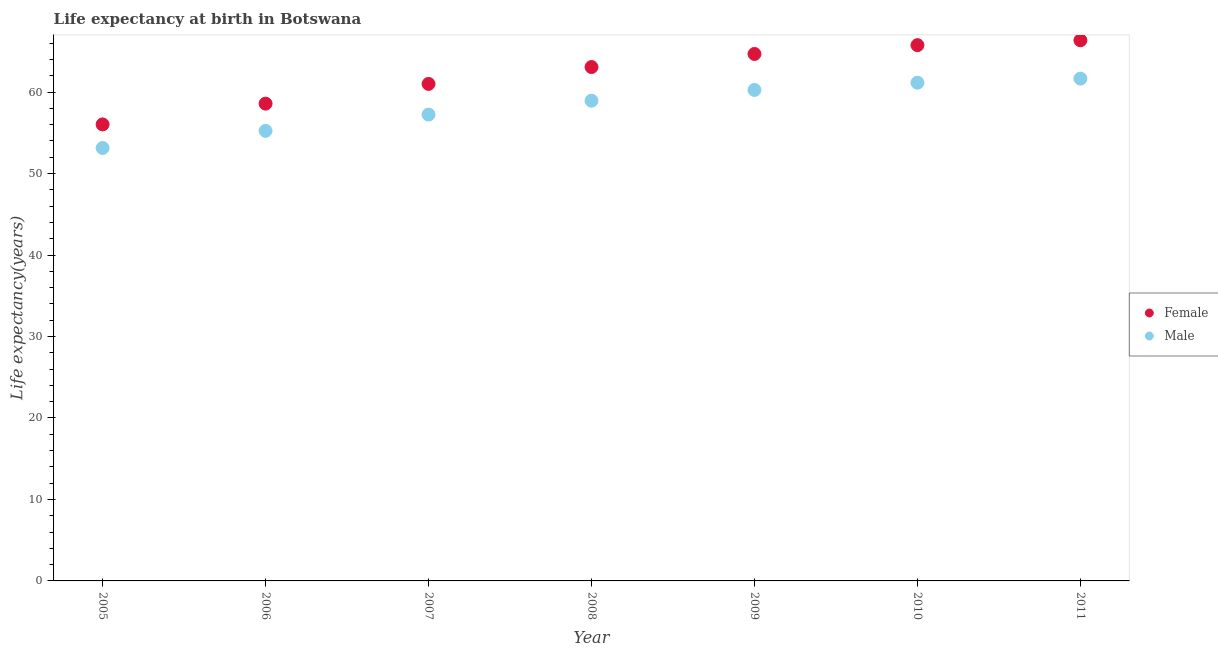Is the number of dotlines equal to the number of legend labels?
Offer a terse response. Yes. What is the life expectancy(male) in 2005?
Give a very brief answer. 53.14. Across all years, what is the maximum life expectancy(female)?
Your response must be concise. 66.36. Across all years, what is the minimum life expectancy(male)?
Offer a very short reply. 53.14. In which year was the life expectancy(male) maximum?
Make the answer very short. 2011. In which year was the life expectancy(female) minimum?
Your answer should be compact. 2005. What is the total life expectancy(male) in the graph?
Offer a very short reply. 407.64. What is the difference between the life expectancy(male) in 2005 and that in 2009?
Provide a succinct answer. -7.12. What is the difference between the life expectancy(female) in 2007 and the life expectancy(male) in 2006?
Make the answer very short. 5.76. What is the average life expectancy(male) per year?
Make the answer very short. 58.23. In the year 2007, what is the difference between the life expectancy(male) and life expectancy(female)?
Your answer should be very brief. -3.77. In how many years, is the life expectancy(male) greater than 46 years?
Give a very brief answer. 7. What is the ratio of the life expectancy(female) in 2006 to that in 2008?
Keep it short and to the point. 0.93. Is the life expectancy(female) in 2007 less than that in 2010?
Your answer should be compact. Yes. What is the difference between the highest and the second highest life expectancy(male)?
Give a very brief answer. 0.5. What is the difference between the highest and the lowest life expectancy(male)?
Provide a short and direct response. 8.52. In how many years, is the life expectancy(female) greater than the average life expectancy(female) taken over all years?
Offer a terse response. 4. Is the sum of the life expectancy(female) in 2007 and 2010 greater than the maximum life expectancy(male) across all years?
Your answer should be very brief. Yes. Does the life expectancy(female) monotonically increase over the years?
Keep it short and to the point. Yes. Is the life expectancy(female) strictly less than the life expectancy(male) over the years?
Give a very brief answer. No. How many dotlines are there?
Provide a short and direct response. 2. How many years are there in the graph?
Offer a very short reply. 7. Does the graph contain any zero values?
Offer a very short reply. No. Where does the legend appear in the graph?
Your answer should be compact. Center right. What is the title of the graph?
Your answer should be very brief. Life expectancy at birth in Botswana. What is the label or title of the Y-axis?
Your answer should be very brief. Life expectancy(years). What is the Life expectancy(years) of Female in 2005?
Your answer should be compact. 56.03. What is the Life expectancy(years) in Male in 2005?
Ensure brevity in your answer.  53.14. What is the Life expectancy(years) in Female in 2006?
Make the answer very short. 58.58. What is the Life expectancy(years) in Male in 2006?
Ensure brevity in your answer.  55.24. What is the Life expectancy(years) in Female in 2007?
Provide a short and direct response. 61. What is the Life expectancy(years) in Male in 2007?
Keep it short and to the point. 57.24. What is the Life expectancy(years) in Female in 2008?
Keep it short and to the point. 63.08. What is the Life expectancy(years) of Male in 2008?
Provide a succinct answer. 58.94. What is the Life expectancy(years) of Female in 2009?
Provide a short and direct response. 64.68. What is the Life expectancy(years) in Male in 2009?
Give a very brief answer. 60.26. What is the Life expectancy(years) in Female in 2010?
Your answer should be very brief. 65.76. What is the Life expectancy(years) in Male in 2010?
Your response must be concise. 61.15. What is the Life expectancy(years) in Female in 2011?
Your response must be concise. 66.36. What is the Life expectancy(years) in Male in 2011?
Provide a short and direct response. 61.66. Across all years, what is the maximum Life expectancy(years) in Female?
Offer a terse response. 66.36. Across all years, what is the maximum Life expectancy(years) of Male?
Give a very brief answer. 61.66. Across all years, what is the minimum Life expectancy(years) of Female?
Offer a terse response. 56.03. Across all years, what is the minimum Life expectancy(years) in Male?
Keep it short and to the point. 53.14. What is the total Life expectancy(years) in Female in the graph?
Give a very brief answer. 435.5. What is the total Life expectancy(years) in Male in the graph?
Offer a very short reply. 407.63. What is the difference between the Life expectancy(years) in Female in 2005 and that in 2006?
Your answer should be very brief. -2.55. What is the difference between the Life expectancy(years) of Male in 2005 and that in 2006?
Keep it short and to the point. -2.1. What is the difference between the Life expectancy(years) of Female in 2005 and that in 2007?
Your response must be concise. -4.97. What is the difference between the Life expectancy(years) in Male in 2005 and that in 2007?
Your response must be concise. -4.1. What is the difference between the Life expectancy(years) of Female in 2005 and that in 2008?
Provide a succinct answer. -7.04. What is the difference between the Life expectancy(years) in Male in 2005 and that in 2008?
Your answer should be compact. -5.8. What is the difference between the Life expectancy(years) in Female in 2005 and that in 2009?
Offer a terse response. -8.65. What is the difference between the Life expectancy(years) in Male in 2005 and that in 2009?
Ensure brevity in your answer.  -7.12. What is the difference between the Life expectancy(years) of Female in 2005 and that in 2010?
Keep it short and to the point. -9.73. What is the difference between the Life expectancy(years) of Male in 2005 and that in 2010?
Your response must be concise. -8.01. What is the difference between the Life expectancy(years) of Female in 2005 and that in 2011?
Offer a very short reply. -10.33. What is the difference between the Life expectancy(years) of Male in 2005 and that in 2011?
Your answer should be very brief. -8.52. What is the difference between the Life expectancy(years) of Female in 2006 and that in 2007?
Provide a short and direct response. -2.42. What is the difference between the Life expectancy(years) in Male in 2006 and that in 2007?
Offer a very short reply. -1.99. What is the difference between the Life expectancy(years) of Female in 2006 and that in 2008?
Give a very brief answer. -4.49. What is the difference between the Life expectancy(years) in Male in 2006 and that in 2008?
Make the answer very short. -3.7. What is the difference between the Life expectancy(years) of Female in 2006 and that in 2009?
Provide a short and direct response. -6.1. What is the difference between the Life expectancy(years) in Male in 2006 and that in 2009?
Offer a very short reply. -5.02. What is the difference between the Life expectancy(years) in Female in 2006 and that in 2010?
Your answer should be compact. -7.18. What is the difference between the Life expectancy(years) in Male in 2006 and that in 2010?
Your answer should be very brief. -5.91. What is the difference between the Life expectancy(years) in Female in 2006 and that in 2011?
Provide a short and direct response. -7.78. What is the difference between the Life expectancy(years) in Male in 2006 and that in 2011?
Provide a short and direct response. -6.41. What is the difference between the Life expectancy(years) of Female in 2007 and that in 2008?
Keep it short and to the point. -2.07. What is the difference between the Life expectancy(years) of Male in 2007 and that in 2008?
Offer a very short reply. -1.71. What is the difference between the Life expectancy(years) in Female in 2007 and that in 2009?
Offer a very short reply. -3.68. What is the difference between the Life expectancy(years) of Male in 2007 and that in 2009?
Your answer should be very brief. -3.02. What is the difference between the Life expectancy(years) of Female in 2007 and that in 2010?
Your answer should be very brief. -4.76. What is the difference between the Life expectancy(years) in Male in 2007 and that in 2010?
Make the answer very short. -3.92. What is the difference between the Life expectancy(years) in Female in 2007 and that in 2011?
Make the answer very short. -5.36. What is the difference between the Life expectancy(years) in Male in 2007 and that in 2011?
Offer a very short reply. -4.42. What is the difference between the Life expectancy(years) of Female in 2008 and that in 2009?
Ensure brevity in your answer.  -1.6. What is the difference between the Life expectancy(years) in Male in 2008 and that in 2009?
Make the answer very short. -1.32. What is the difference between the Life expectancy(years) in Female in 2008 and that in 2010?
Your response must be concise. -2.69. What is the difference between the Life expectancy(years) in Male in 2008 and that in 2010?
Your answer should be compact. -2.21. What is the difference between the Life expectancy(years) of Female in 2008 and that in 2011?
Provide a succinct answer. -3.29. What is the difference between the Life expectancy(years) in Male in 2008 and that in 2011?
Keep it short and to the point. -2.71. What is the difference between the Life expectancy(years) in Female in 2009 and that in 2010?
Provide a succinct answer. -1.08. What is the difference between the Life expectancy(years) of Male in 2009 and that in 2010?
Provide a short and direct response. -0.89. What is the difference between the Life expectancy(years) of Female in 2009 and that in 2011?
Give a very brief answer. -1.68. What is the difference between the Life expectancy(years) of Male in 2009 and that in 2011?
Ensure brevity in your answer.  -1.4. What is the difference between the Life expectancy(years) in Female in 2010 and that in 2011?
Keep it short and to the point. -0.6. What is the difference between the Life expectancy(years) in Male in 2010 and that in 2011?
Your response must be concise. -0.5. What is the difference between the Life expectancy(years) of Female in 2005 and the Life expectancy(years) of Male in 2006?
Your response must be concise. 0.79. What is the difference between the Life expectancy(years) of Female in 2005 and the Life expectancy(years) of Male in 2007?
Give a very brief answer. -1.2. What is the difference between the Life expectancy(years) of Female in 2005 and the Life expectancy(years) of Male in 2008?
Give a very brief answer. -2.91. What is the difference between the Life expectancy(years) of Female in 2005 and the Life expectancy(years) of Male in 2009?
Your answer should be very brief. -4.23. What is the difference between the Life expectancy(years) in Female in 2005 and the Life expectancy(years) in Male in 2010?
Keep it short and to the point. -5.12. What is the difference between the Life expectancy(years) of Female in 2005 and the Life expectancy(years) of Male in 2011?
Offer a terse response. -5.62. What is the difference between the Life expectancy(years) of Female in 2006 and the Life expectancy(years) of Male in 2007?
Ensure brevity in your answer.  1.35. What is the difference between the Life expectancy(years) of Female in 2006 and the Life expectancy(years) of Male in 2008?
Make the answer very short. -0.36. What is the difference between the Life expectancy(years) of Female in 2006 and the Life expectancy(years) of Male in 2009?
Ensure brevity in your answer.  -1.68. What is the difference between the Life expectancy(years) in Female in 2006 and the Life expectancy(years) in Male in 2010?
Your answer should be very brief. -2.57. What is the difference between the Life expectancy(years) of Female in 2006 and the Life expectancy(years) of Male in 2011?
Keep it short and to the point. -3.07. What is the difference between the Life expectancy(years) in Female in 2007 and the Life expectancy(years) in Male in 2008?
Provide a succinct answer. 2.06. What is the difference between the Life expectancy(years) in Female in 2007 and the Life expectancy(years) in Male in 2009?
Your answer should be very brief. 0.74. What is the difference between the Life expectancy(years) in Female in 2007 and the Life expectancy(years) in Male in 2011?
Offer a terse response. -0.65. What is the difference between the Life expectancy(years) in Female in 2008 and the Life expectancy(years) in Male in 2009?
Your response must be concise. 2.81. What is the difference between the Life expectancy(years) of Female in 2008 and the Life expectancy(years) of Male in 2010?
Ensure brevity in your answer.  1.92. What is the difference between the Life expectancy(years) of Female in 2008 and the Life expectancy(years) of Male in 2011?
Your answer should be compact. 1.42. What is the difference between the Life expectancy(years) of Female in 2009 and the Life expectancy(years) of Male in 2010?
Your answer should be very brief. 3.53. What is the difference between the Life expectancy(years) in Female in 2009 and the Life expectancy(years) in Male in 2011?
Provide a succinct answer. 3.02. What is the difference between the Life expectancy(years) in Female in 2010 and the Life expectancy(years) in Male in 2011?
Your answer should be very brief. 4.11. What is the average Life expectancy(years) in Female per year?
Your response must be concise. 62.21. What is the average Life expectancy(years) of Male per year?
Your response must be concise. 58.23. In the year 2005, what is the difference between the Life expectancy(years) of Female and Life expectancy(years) of Male?
Ensure brevity in your answer.  2.89. In the year 2006, what is the difference between the Life expectancy(years) in Female and Life expectancy(years) in Male?
Make the answer very short. 3.34. In the year 2007, what is the difference between the Life expectancy(years) in Female and Life expectancy(years) in Male?
Provide a succinct answer. 3.77. In the year 2008, what is the difference between the Life expectancy(years) of Female and Life expectancy(years) of Male?
Your answer should be very brief. 4.13. In the year 2009, what is the difference between the Life expectancy(years) of Female and Life expectancy(years) of Male?
Your answer should be compact. 4.42. In the year 2010, what is the difference between the Life expectancy(years) of Female and Life expectancy(years) of Male?
Make the answer very short. 4.61. In the year 2011, what is the difference between the Life expectancy(years) in Female and Life expectancy(years) in Male?
Ensure brevity in your answer.  4.71. What is the ratio of the Life expectancy(years) of Female in 2005 to that in 2006?
Make the answer very short. 0.96. What is the ratio of the Life expectancy(years) of Male in 2005 to that in 2006?
Offer a very short reply. 0.96. What is the ratio of the Life expectancy(years) in Female in 2005 to that in 2007?
Your answer should be compact. 0.92. What is the ratio of the Life expectancy(years) in Male in 2005 to that in 2007?
Ensure brevity in your answer.  0.93. What is the ratio of the Life expectancy(years) in Female in 2005 to that in 2008?
Provide a succinct answer. 0.89. What is the ratio of the Life expectancy(years) of Male in 2005 to that in 2008?
Ensure brevity in your answer.  0.9. What is the ratio of the Life expectancy(years) of Female in 2005 to that in 2009?
Keep it short and to the point. 0.87. What is the ratio of the Life expectancy(years) of Male in 2005 to that in 2009?
Offer a terse response. 0.88. What is the ratio of the Life expectancy(years) in Female in 2005 to that in 2010?
Make the answer very short. 0.85. What is the ratio of the Life expectancy(years) of Male in 2005 to that in 2010?
Offer a terse response. 0.87. What is the ratio of the Life expectancy(years) in Female in 2005 to that in 2011?
Ensure brevity in your answer.  0.84. What is the ratio of the Life expectancy(years) of Male in 2005 to that in 2011?
Keep it short and to the point. 0.86. What is the ratio of the Life expectancy(years) of Female in 2006 to that in 2007?
Ensure brevity in your answer.  0.96. What is the ratio of the Life expectancy(years) in Male in 2006 to that in 2007?
Provide a succinct answer. 0.97. What is the ratio of the Life expectancy(years) in Female in 2006 to that in 2008?
Offer a terse response. 0.93. What is the ratio of the Life expectancy(years) in Male in 2006 to that in 2008?
Offer a terse response. 0.94. What is the ratio of the Life expectancy(years) of Female in 2006 to that in 2009?
Your answer should be compact. 0.91. What is the ratio of the Life expectancy(years) in Male in 2006 to that in 2009?
Your answer should be compact. 0.92. What is the ratio of the Life expectancy(years) in Female in 2006 to that in 2010?
Provide a short and direct response. 0.89. What is the ratio of the Life expectancy(years) in Male in 2006 to that in 2010?
Your answer should be very brief. 0.9. What is the ratio of the Life expectancy(years) in Female in 2006 to that in 2011?
Provide a short and direct response. 0.88. What is the ratio of the Life expectancy(years) in Male in 2006 to that in 2011?
Your answer should be very brief. 0.9. What is the ratio of the Life expectancy(years) in Female in 2007 to that in 2008?
Your response must be concise. 0.97. What is the ratio of the Life expectancy(years) in Male in 2007 to that in 2008?
Give a very brief answer. 0.97. What is the ratio of the Life expectancy(years) of Female in 2007 to that in 2009?
Your answer should be very brief. 0.94. What is the ratio of the Life expectancy(years) in Male in 2007 to that in 2009?
Offer a very short reply. 0.95. What is the ratio of the Life expectancy(years) of Female in 2007 to that in 2010?
Make the answer very short. 0.93. What is the ratio of the Life expectancy(years) of Male in 2007 to that in 2010?
Offer a very short reply. 0.94. What is the ratio of the Life expectancy(years) in Female in 2007 to that in 2011?
Make the answer very short. 0.92. What is the ratio of the Life expectancy(years) of Male in 2007 to that in 2011?
Provide a succinct answer. 0.93. What is the ratio of the Life expectancy(years) in Female in 2008 to that in 2009?
Your response must be concise. 0.98. What is the ratio of the Life expectancy(years) of Male in 2008 to that in 2009?
Your answer should be very brief. 0.98. What is the ratio of the Life expectancy(years) of Female in 2008 to that in 2010?
Keep it short and to the point. 0.96. What is the ratio of the Life expectancy(years) of Male in 2008 to that in 2010?
Make the answer very short. 0.96. What is the ratio of the Life expectancy(years) in Female in 2008 to that in 2011?
Your answer should be very brief. 0.95. What is the ratio of the Life expectancy(years) of Male in 2008 to that in 2011?
Offer a terse response. 0.96. What is the ratio of the Life expectancy(years) of Female in 2009 to that in 2010?
Make the answer very short. 0.98. What is the ratio of the Life expectancy(years) in Male in 2009 to that in 2010?
Offer a terse response. 0.99. What is the ratio of the Life expectancy(years) of Female in 2009 to that in 2011?
Offer a very short reply. 0.97. What is the ratio of the Life expectancy(years) of Male in 2009 to that in 2011?
Give a very brief answer. 0.98. What is the difference between the highest and the second highest Life expectancy(years) of Female?
Your answer should be compact. 0.6. What is the difference between the highest and the second highest Life expectancy(years) in Male?
Your response must be concise. 0.5. What is the difference between the highest and the lowest Life expectancy(years) of Female?
Your response must be concise. 10.33. What is the difference between the highest and the lowest Life expectancy(years) of Male?
Your answer should be compact. 8.52. 